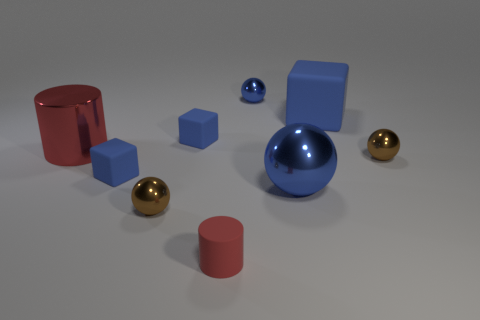Is there anything else that has the same color as the tiny rubber cylinder? Yes, the larger cylindrical object near the center of the image shares the same vibrant, glossy red color as the tiny rubber cylinder. Both items stand out with their reflective surfaces, suggesting they might be made of similar materials. 